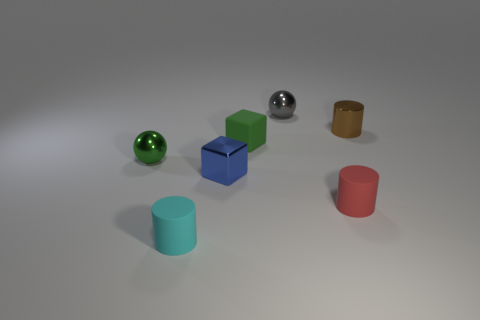Subtract all brown cylinders. How many cylinders are left? 2 Add 1 green rubber objects. How many objects exist? 8 Subtract all brown cylinders. How many cylinders are left? 2 Subtract 0 purple cylinders. How many objects are left? 7 Subtract all balls. How many objects are left? 5 Subtract 1 spheres. How many spheres are left? 1 Subtract all gray balls. Subtract all gray blocks. How many balls are left? 1 Subtract all red spheres. How many purple blocks are left? 0 Subtract all small red rubber objects. Subtract all tiny blue matte objects. How many objects are left? 6 Add 2 green objects. How many green objects are left? 4 